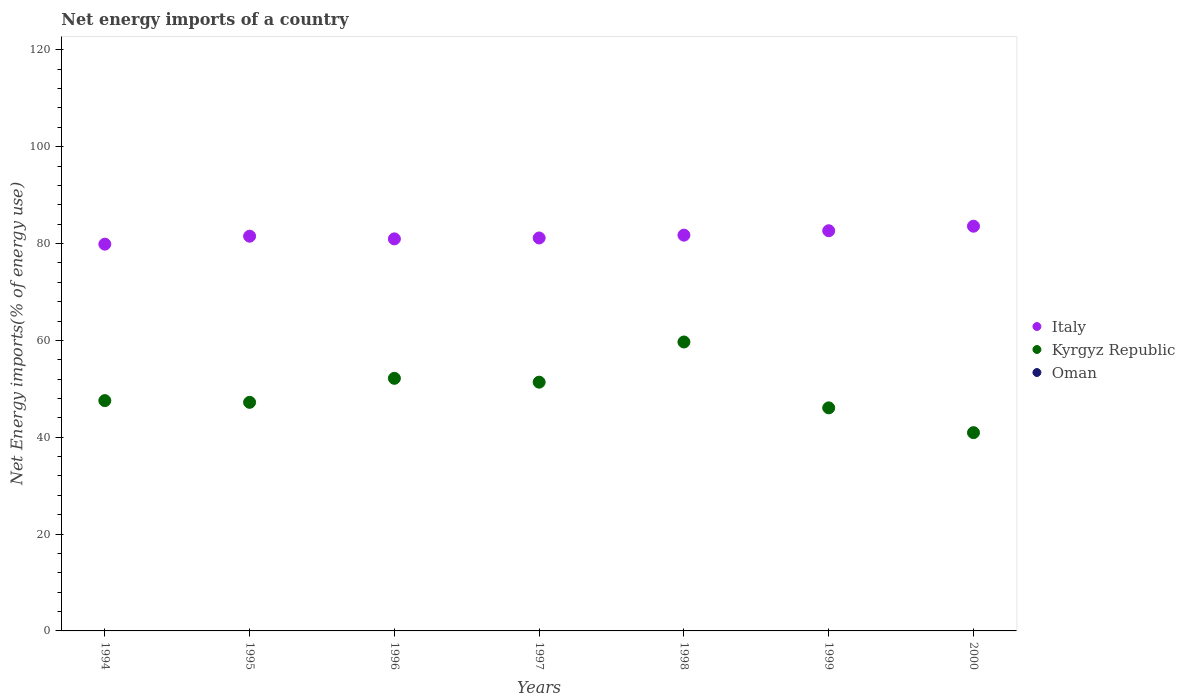Is the number of dotlines equal to the number of legend labels?
Your answer should be compact. No. What is the net energy imports in Italy in 1996?
Keep it short and to the point. 80.96. Across all years, what is the maximum net energy imports in Italy?
Ensure brevity in your answer.  83.58. Across all years, what is the minimum net energy imports in Italy?
Ensure brevity in your answer.  79.87. What is the total net energy imports in Oman in the graph?
Offer a very short reply. 0. What is the difference between the net energy imports in Kyrgyz Republic in 1998 and that in 1999?
Provide a succinct answer. 13.6. What is the difference between the net energy imports in Kyrgyz Republic in 1994 and the net energy imports in Italy in 1999?
Keep it short and to the point. -35.08. What is the average net energy imports in Kyrgyz Republic per year?
Keep it short and to the point. 49.28. In the year 1998, what is the difference between the net energy imports in Italy and net energy imports in Kyrgyz Republic?
Make the answer very short. 22.06. What is the ratio of the net energy imports in Italy in 1996 to that in 2000?
Keep it short and to the point. 0.97. Is the net energy imports in Kyrgyz Republic in 1997 less than that in 2000?
Offer a terse response. No. What is the difference between the highest and the second highest net energy imports in Kyrgyz Republic?
Provide a succinct answer. 7.5. What is the difference between the highest and the lowest net energy imports in Kyrgyz Republic?
Your answer should be compact. 18.72. In how many years, is the net energy imports in Kyrgyz Republic greater than the average net energy imports in Kyrgyz Republic taken over all years?
Offer a very short reply. 3. Is the sum of the net energy imports in Italy in 1998 and 2000 greater than the maximum net energy imports in Oman across all years?
Provide a short and direct response. Yes. How many years are there in the graph?
Your answer should be compact. 7. Does the graph contain any zero values?
Provide a succinct answer. Yes. Does the graph contain grids?
Keep it short and to the point. No. Where does the legend appear in the graph?
Keep it short and to the point. Center right. How many legend labels are there?
Your response must be concise. 3. How are the legend labels stacked?
Make the answer very short. Vertical. What is the title of the graph?
Offer a terse response. Net energy imports of a country. Does "Other small states" appear as one of the legend labels in the graph?
Your answer should be compact. No. What is the label or title of the Y-axis?
Keep it short and to the point. Net Energy imports(% of energy use). What is the Net Energy imports(% of energy use) in Italy in 1994?
Ensure brevity in your answer.  79.87. What is the Net Energy imports(% of energy use) in Kyrgyz Republic in 1994?
Your answer should be very brief. 47.56. What is the Net Energy imports(% of energy use) in Oman in 1994?
Provide a short and direct response. 0. What is the Net Energy imports(% of energy use) in Italy in 1995?
Provide a short and direct response. 81.51. What is the Net Energy imports(% of energy use) of Kyrgyz Republic in 1995?
Offer a terse response. 47.2. What is the Net Energy imports(% of energy use) in Italy in 1996?
Keep it short and to the point. 80.96. What is the Net Energy imports(% of energy use) in Kyrgyz Republic in 1996?
Provide a succinct answer. 52.16. What is the Net Energy imports(% of energy use) in Oman in 1996?
Provide a succinct answer. 0. What is the Net Energy imports(% of energy use) of Italy in 1997?
Keep it short and to the point. 81.15. What is the Net Energy imports(% of energy use) in Kyrgyz Republic in 1997?
Give a very brief answer. 51.37. What is the Net Energy imports(% of energy use) in Italy in 1998?
Provide a short and direct response. 81.73. What is the Net Energy imports(% of energy use) in Kyrgyz Republic in 1998?
Your answer should be compact. 59.67. What is the Net Energy imports(% of energy use) in Italy in 1999?
Make the answer very short. 82.64. What is the Net Energy imports(% of energy use) in Kyrgyz Republic in 1999?
Ensure brevity in your answer.  46.06. What is the Net Energy imports(% of energy use) in Italy in 2000?
Provide a short and direct response. 83.58. What is the Net Energy imports(% of energy use) of Kyrgyz Republic in 2000?
Ensure brevity in your answer.  40.94. Across all years, what is the maximum Net Energy imports(% of energy use) in Italy?
Provide a succinct answer. 83.58. Across all years, what is the maximum Net Energy imports(% of energy use) in Kyrgyz Republic?
Your response must be concise. 59.67. Across all years, what is the minimum Net Energy imports(% of energy use) of Italy?
Provide a succinct answer. 79.87. Across all years, what is the minimum Net Energy imports(% of energy use) in Kyrgyz Republic?
Provide a succinct answer. 40.94. What is the total Net Energy imports(% of energy use) in Italy in the graph?
Make the answer very short. 571.43. What is the total Net Energy imports(% of energy use) of Kyrgyz Republic in the graph?
Offer a terse response. 344.97. What is the total Net Energy imports(% of energy use) in Oman in the graph?
Your response must be concise. 0. What is the difference between the Net Energy imports(% of energy use) of Italy in 1994 and that in 1995?
Your answer should be compact. -1.64. What is the difference between the Net Energy imports(% of energy use) in Kyrgyz Republic in 1994 and that in 1995?
Ensure brevity in your answer.  0.35. What is the difference between the Net Energy imports(% of energy use) of Italy in 1994 and that in 1996?
Offer a very short reply. -1.09. What is the difference between the Net Energy imports(% of energy use) in Kyrgyz Republic in 1994 and that in 1996?
Offer a very short reply. -4.6. What is the difference between the Net Energy imports(% of energy use) of Italy in 1994 and that in 1997?
Your answer should be compact. -1.28. What is the difference between the Net Energy imports(% of energy use) of Kyrgyz Republic in 1994 and that in 1997?
Offer a terse response. -3.81. What is the difference between the Net Energy imports(% of energy use) of Italy in 1994 and that in 1998?
Your response must be concise. -1.86. What is the difference between the Net Energy imports(% of energy use) of Kyrgyz Republic in 1994 and that in 1998?
Make the answer very short. -12.11. What is the difference between the Net Energy imports(% of energy use) of Italy in 1994 and that in 1999?
Provide a succinct answer. -2.77. What is the difference between the Net Energy imports(% of energy use) of Kyrgyz Republic in 1994 and that in 1999?
Your answer should be compact. 1.49. What is the difference between the Net Energy imports(% of energy use) of Italy in 1994 and that in 2000?
Keep it short and to the point. -3.71. What is the difference between the Net Energy imports(% of energy use) in Kyrgyz Republic in 1994 and that in 2000?
Provide a short and direct response. 6.62. What is the difference between the Net Energy imports(% of energy use) of Italy in 1995 and that in 1996?
Provide a succinct answer. 0.55. What is the difference between the Net Energy imports(% of energy use) of Kyrgyz Republic in 1995 and that in 1996?
Give a very brief answer. -4.96. What is the difference between the Net Energy imports(% of energy use) in Italy in 1995 and that in 1997?
Give a very brief answer. 0.37. What is the difference between the Net Energy imports(% of energy use) in Kyrgyz Republic in 1995 and that in 1997?
Offer a very short reply. -4.16. What is the difference between the Net Energy imports(% of energy use) of Italy in 1995 and that in 1998?
Offer a terse response. -0.22. What is the difference between the Net Energy imports(% of energy use) of Kyrgyz Republic in 1995 and that in 1998?
Your answer should be very brief. -12.46. What is the difference between the Net Energy imports(% of energy use) of Italy in 1995 and that in 1999?
Ensure brevity in your answer.  -1.13. What is the difference between the Net Energy imports(% of energy use) of Kyrgyz Republic in 1995 and that in 1999?
Make the answer very short. 1.14. What is the difference between the Net Energy imports(% of energy use) of Italy in 1995 and that in 2000?
Keep it short and to the point. -2.06. What is the difference between the Net Energy imports(% of energy use) in Kyrgyz Republic in 1995 and that in 2000?
Your answer should be compact. 6.26. What is the difference between the Net Energy imports(% of energy use) of Italy in 1996 and that in 1997?
Your response must be concise. -0.18. What is the difference between the Net Energy imports(% of energy use) of Kyrgyz Republic in 1996 and that in 1997?
Ensure brevity in your answer.  0.79. What is the difference between the Net Energy imports(% of energy use) in Italy in 1996 and that in 1998?
Give a very brief answer. -0.77. What is the difference between the Net Energy imports(% of energy use) of Kyrgyz Republic in 1996 and that in 1998?
Give a very brief answer. -7.5. What is the difference between the Net Energy imports(% of energy use) in Italy in 1996 and that in 1999?
Give a very brief answer. -1.68. What is the difference between the Net Energy imports(% of energy use) in Kyrgyz Republic in 1996 and that in 1999?
Ensure brevity in your answer.  6.1. What is the difference between the Net Energy imports(% of energy use) of Italy in 1996 and that in 2000?
Your response must be concise. -2.62. What is the difference between the Net Energy imports(% of energy use) in Kyrgyz Republic in 1996 and that in 2000?
Offer a very short reply. 11.22. What is the difference between the Net Energy imports(% of energy use) of Italy in 1997 and that in 1998?
Your response must be concise. -0.58. What is the difference between the Net Energy imports(% of energy use) of Kyrgyz Republic in 1997 and that in 1998?
Provide a short and direct response. -8.3. What is the difference between the Net Energy imports(% of energy use) in Italy in 1997 and that in 1999?
Offer a very short reply. -1.49. What is the difference between the Net Energy imports(% of energy use) in Kyrgyz Republic in 1997 and that in 1999?
Your answer should be very brief. 5.3. What is the difference between the Net Energy imports(% of energy use) of Italy in 1997 and that in 2000?
Offer a very short reply. -2.43. What is the difference between the Net Energy imports(% of energy use) in Kyrgyz Republic in 1997 and that in 2000?
Your answer should be compact. 10.43. What is the difference between the Net Energy imports(% of energy use) of Italy in 1998 and that in 1999?
Your answer should be very brief. -0.91. What is the difference between the Net Energy imports(% of energy use) in Kyrgyz Republic in 1998 and that in 1999?
Keep it short and to the point. 13.6. What is the difference between the Net Energy imports(% of energy use) in Italy in 1998 and that in 2000?
Give a very brief answer. -1.85. What is the difference between the Net Energy imports(% of energy use) of Kyrgyz Republic in 1998 and that in 2000?
Give a very brief answer. 18.72. What is the difference between the Net Energy imports(% of energy use) in Italy in 1999 and that in 2000?
Your answer should be compact. -0.94. What is the difference between the Net Energy imports(% of energy use) of Kyrgyz Republic in 1999 and that in 2000?
Offer a terse response. 5.12. What is the difference between the Net Energy imports(% of energy use) in Italy in 1994 and the Net Energy imports(% of energy use) in Kyrgyz Republic in 1995?
Provide a short and direct response. 32.67. What is the difference between the Net Energy imports(% of energy use) in Italy in 1994 and the Net Energy imports(% of energy use) in Kyrgyz Republic in 1996?
Ensure brevity in your answer.  27.71. What is the difference between the Net Energy imports(% of energy use) in Italy in 1994 and the Net Energy imports(% of energy use) in Kyrgyz Republic in 1997?
Keep it short and to the point. 28.5. What is the difference between the Net Energy imports(% of energy use) in Italy in 1994 and the Net Energy imports(% of energy use) in Kyrgyz Republic in 1998?
Your response must be concise. 20.21. What is the difference between the Net Energy imports(% of energy use) in Italy in 1994 and the Net Energy imports(% of energy use) in Kyrgyz Republic in 1999?
Provide a succinct answer. 33.81. What is the difference between the Net Energy imports(% of energy use) of Italy in 1994 and the Net Energy imports(% of energy use) of Kyrgyz Republic in 2000?
Keep it short and to the point. 38.93. What is the difference between the Net Energy imports(% of energy use) of Italy in 1995 and the Net Energy imports(% of energy use) of Kyrgyz Republic in 1996?
Your answer should be very brief. 29.35. What is the difference between the Net Energy imports(% of energy use) in Italy in 1995 and the Net Energy imports(% of energy use) in Kyrgyz Republic in 1997?
Keep it short and to the point. 30.14. What is the difference between the Net Energy imports(% of energy use) in Italy in 1995 and the Net Energy imports(% of energy use) in Kyrgyz Republic in 1998?
Provide a short and direct response. 21.85. What is the difference between the Net Energy imports(% of energy use) in Italy in 1995 and the Net Energy imports(% of energy use) in Kyrgyz Republic in 1999?
Your response must be concise. 35.45. What is the difference between the Net Energy imports(% of energy use) in Italy in 1995 and the Net Energy imports(% of energy use) in Kyrgyz Republic in 2000?
Offer a terse response. 40.57. What is the difference between the Net Energy imports(% of energy use) in Italy in 1996 and the Net Energy imports(% of energy use) in Kyrgyz Republic in 1997?
Make the answer very short. 29.59. What is the difference between the Net Energy imports(% of energy use) of Italy in 1996 and the Net Energy imports(% of energy use) of Kyrgyz Republic in 1998?
Offer a very short reply. 21.3. What is the difference between the Net Energy imports(% of energy use) of Italy in 1996 and the Net Energy imports(% of energy use) of Kyrgyz Republic in 1999?
Provide a succinct answer. 34.9. What is the difference between the Net Energy imports(% of energy use) in Italy in 1996 and the Net Energy imports(% of energy use) in Kyrgyz Republic in 2000?
Give a very brief answer. 40.02. What is the difference between the Net Energy imports(% of energy use) of Italy in 1997 and the Net Energy imports(% of energy use) of Kyrgyz Republic in 1998?
Make the answer very short. 21.48. What is the difference between the Net Energy imports(% of energy use) of Italy in 1997 and the Net Energy imports(% of energy use) of Kyrgyz Republic in 1999?
Offer a very short reply. 35.08. What is the difference between the Net Energy imports(% of energy use) of Italy in 1997 and the Net Energy imports(% of energy use) of Kyrgyz Republic in 2000?
Your answer should be very brief. 40.2. What is the difference between the Net Energy imports(% of energy use) of Italy in 1998 and the Net Energy imports(% of energy use) of Kyrgyz Republic in 1999?
Make the answer very short. 35.66. What is the difference between the Net Energy imports(% of energy use) in Italy in 1998 and the Net Energy imports(% of energy use) in Kyrgyz Republic in 2000?
Offer a very short reply. 40.79. What is the difference between the Net Energy imports(% of energy use) in Italy in 1999 and the Net Energy imports(% of energy use) in Kyrgyz Republic in 2000?
Your response must be concise. 41.7. What is the average Net Energy imports(% of energy use) in Italy per year?
Ensure brevity in your answer.  81.63. What is the average Net Energy imports(% of energy use) of Kyrgyz Republic per year?
Ensure brevity in your answer.  49.28. In the year 1994, what is the difference between the Net Energy imports(% of energy use) in Italy and Net Energy imports(% of energy use) in Kyrgyz Republic?
Your answer should be compact. 32.31. In the year 1995, what is the difference between the Net Energy imports(% of energy use) of Italy and Net Energy imports(% of energy use) of Kyrgyz Republic?
Offer a very short reply. 34.31. In the year 1996, what is the difference between the Net Energy imports(% of energy use) in Italy and Net Energy imports(% of energy use) in Kyrgyz Republic?
Offer a very short reply. 28.8. In the year 1997, what is the difference between the Net Energy imports(% of energy use) of Italy and Net Energy imports(% of energy use) of Kyrgyz Republic?
Make the answer very short. 29.78. In the year 1998, what is the difference between the Net Energy imports(% of energy use) in Italy and Net Energy imports(% of energy use) in Kyrgyz Republic?
Offer a very short reply. 22.06. In the year 1999, what is the difference between the Net Energy imports(% of energy use) in Italy and Net Energy imports(% of energy use) in Kyrgyz Republic?
Provide a succinct answer. 36.57. In the year 2000, what is the difference between the Net Energy imports(% of energy use) of Italy and Net Energy imports(% of energy use) of Kyrgyz Republic?
Offer a very short reply. 42.63. What is the ratio of the Net Energy imports(% of energy use) in Italy in 1994 to that in 1995?
Provide a short and direct response. 0.98. What is the ratio of the Net Energy imports(% of energy use) in Kyrgyz Republic in 1994 to that in 1995?
Provide a short and direct response. 1.01. What is the ratio of the Net Energy imports(% of energy use) of Italy in 1994 to that in 1996?
Make the answer very short. 0.99. What is the ratio of the Net Energy imports(% of energy use) in Kyrgyz Republic in 1994 to that in 1996?
Your response must be concise. 0.91. What is the ratio of the Net Energy imports(% of energy use) in Italy in 1994 to that in 1997?
Your answer should be very brief. 0.98. What is the ratio of the Net Energy imports(% of energy use) of Kyrgyz Republic in 1994 to that in 1997?
Keep it short and to the point. 0.93. What is the ratio of the Net Energy imports(% of energy use) of Italy in 1994 to that in 1998?
Offer a terse response. 0.98. What is the ratio of the Net Energy imports(% of energy use) of Kyrgyz Republic in 1994 to that in 1998?
Offer a terse response. 0.8. What is the ratio of the Net Energy imports(% of energy use) in Italy in 1994 to that in 1999?
Offer a very short reply. 0.97. What is the ratio of the Net Energy imports(% of energy use) in Kyrgyz Republic in 1994 to that in 1999?
Ensure brevity in your answer.  1.03. What is the ratio of the Net Energy imports(% of energy use) of Italy in 1994 to that in 2000?
Your answer should be compact. 0.96. What is the ratio of the Net Energy imports(% of energy use) of Kyrgyz Republic in 1994 to that in 2000?
Ensure brevity in your answer.  1.16. What is the ratio of the Net Energy imports(% of energy use) in Italy in 1995 to that in 1996?
Give a very brief answer. 1.01. What is the ratio of the Net Energy imports(% of energy use) in Kyrgyz Republic in 1995 to that in 1996?
Keep it short and to the point. 0.91. What is the ratio of the Net Energy imports(% of energy use) in Kyrgyz Republic in 1995 to that in 1997?
Ensure brevity in your answer.  0.92. What is the ratio of the Net Energy imports(% of energy use) of Italy in 1995 to that in 1998?
Your answer should be very brief. 1. What is the ratio of the Net Energy imports(% of energy use) in Kyrgyz Republic in 1995 to that in 1998?
Give a very brief answer. 0.79. What is the ratio of the Net Energy imports(% of energy use) of Italy in 1995 to that in 1999?
Ensure brevity in your answer.  0.99. What is the ratio of the Net Energy imports(% of energy use) of Kyrgyz Republic in 1995 to that in 1999?
Provide a short and direct response. 1.02. What is the ratio of the Net Energy imports(% of energy use) in Italy in 1995 to that in 2000?
Your response must be concise. 0.98. What is the ratio of the Net Energy imports(% of energy use) of Kyrgyz Republic in 1995 to that in 2000?
Your answer should be compact. 1.15. What is the ratio of the Net Energy imports(% of energy use) in Kyrgyz Republic in 1996 to that in 1997?
Make the answer very short. 1.02. What is the ratio of the Net Energy imports(% of energy use) of Italy in 1996 to that in 1998?
Provide a succinct answer. 0.99. What is the ratio of the Net Energy imports(% of energy use) of Kyrgyz Republic in 1996 to that in 1998?
Offer a very short reply. 0.87. What is the ratio of the Net Energy imports(% of energy use) in Italy in 1996 to that in 1999?
Your answer should be compact. 0.98. What is the ratio of the Net Energy imports(% of energy use) in Kyrgyz Republic in 1996 to that in 1999?
Keep it short and to the point. 1.13. What is the ratio of the Net Energy imports(% of energy use) in Italy in 1996 to that in 2000?
Ensure brevity in your answer.  0.97. What is the ratio of the Net Energy imports(% of energy use) in Kyrgyz Republic in 1996 to that in 2000?
Give a very brief answer. 1.27. What is the ratio of the Net Energy imports(% of energy use) of Kyrgyz Republic in 1997 to that in 1998?
Ensure brevity in your answer.  0.86. What is the ratio of the Net Energy imports(% of energy use) of Italy in 1997 to that in 1999?
Offer a terse response. 0.98. What is the ratio of the Net Energy imports(% of energy use) of Kyrgyz Republic in 1997 to that in 1999?
Give a very brief answer. 1.12. What is the ratio of the Net Energy imports(% of energy use) in Italy in 1997 to that in 2000?
Your response must be concise. 0.97. What is the ratio of the Net Energy imports(% of energy use) in Kyrgyz Republic in 1997 to that in 2000?
Give a very brief answer. 1.25. What is the ratio of the Net Energy imports(% of energy use) of Kyrgyz Republic in 1998 to that in 1999?
Offer a very short reply. 1.3. What is the ratio of the Net Energy imports(% of energy use) in Italy in 1998 to that in 2000?
Provide a succinct answer. 0.98. What is the ratio of the Net Energy imports(% of energy use) in Kyrgyz Republic in 1998 to that in 2000?
Your answer should be very brief. 1.46. What is the ratio of the Net Energy imports(% of energy use) of Kyrgyz Republic in 1999 to that in 2000?
Your response must be concise. 1.13. What is the difference between the highest and the second highest Net Energy imports(% of energy use) in Italy?
Provide a succinct answer. 0.94. What is the difference between the highest and the second highest Net Energy imports(% of energy use) of Kyrgyz Republic?
Offer a very short reply. 7.5. What is the difference between the highest and the lowest Net Energy imports(% of energy use) of Italy?
Your answer should be very brief. 3.71. What is the difference between the highest and the lowest Net Energy imports(% of energy use) of Kyrgyz Republic?
Offer a very short reply. 18.72. 